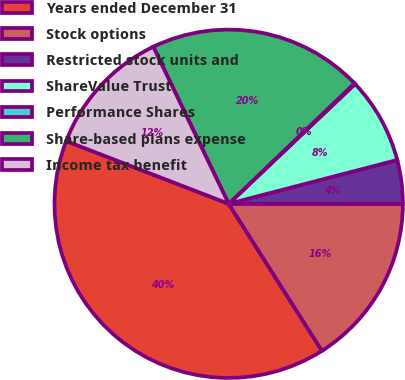Convert chart. <chart><loc_0><loc_0><loc_500><loc_500><pie_chart><fcel>Years ended December 31<fcel>Stock options<fcel>Restricted stock units and<fcel>ShareValue Trust<fcel>Performance Shares<fcel>Share-based plans expense<fcel>Income tax benefit<nl><fcel>39.86%<fcel>15.99%<fcel>4.06%<fcel>8.03%<fcel>0.08%<fcel>19.97%<fcel>12.01%<nl></chart> 